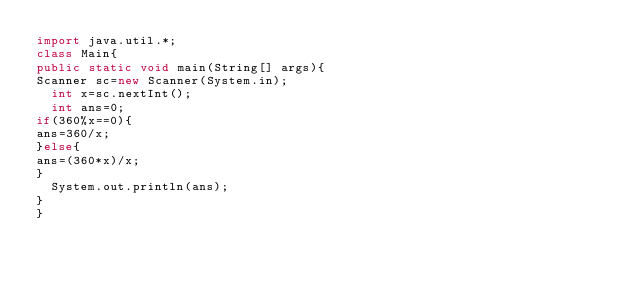Convert code to text. <code><loc_0><loc_0><loc_500><loc_500><_Java_>import java.util.*;
class Main{
public static void main(String[] args){
Scanner sc=new Scanner(System.in);
  int x=sc.nextInt();
  int ans=0;
if(360%x==0){
ans=360/x;
}else{
ans=(360*x)/x;
}
  System.out.println(ans);
}
}</code> 